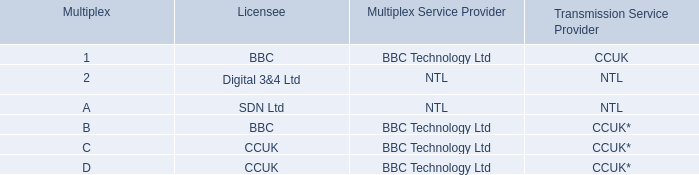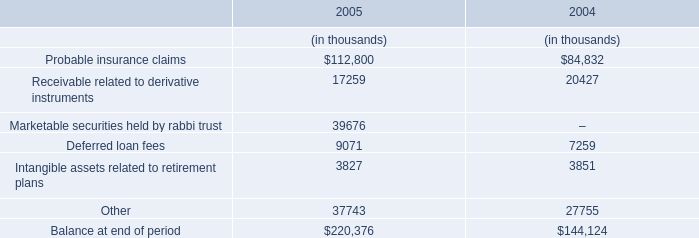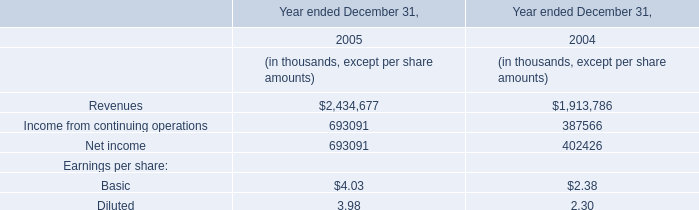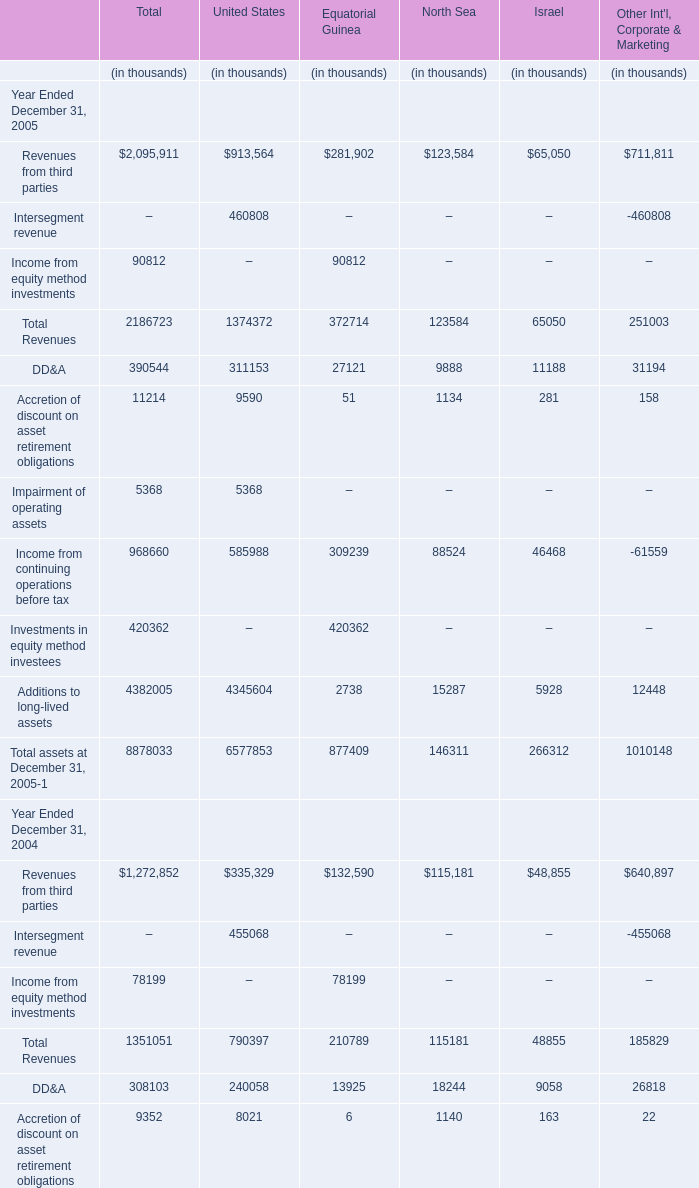What is the ratio of Intersegment revenue of United States in Table 3 to the Other in Table 1 in 2005? 
Computations: (460808 / 37743)
Answer: 12.2091. 